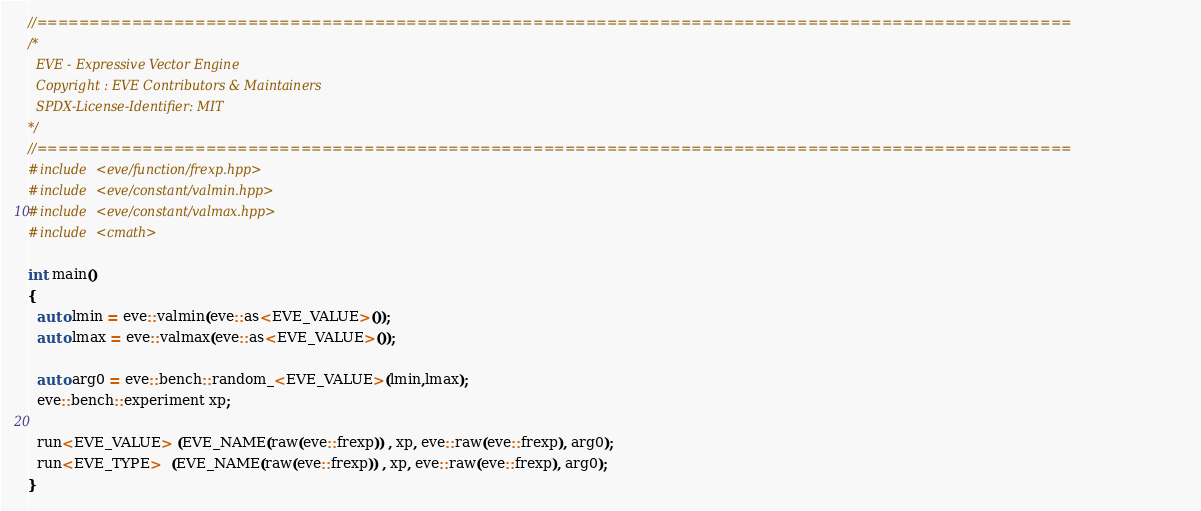Convert code to text. <code><loc_0><loc_0><loc_500><loc_500><_C++_>//==================================================================================================
/*
  EVE - Expressive Vector Engine
  Copyright : EVE Contributors & Maintainers
  SPDX-License-Identifier: MIT
*/
//==================================================================================================
#include <eve/function/frexp.hpp>
#include <eve/constant/valmin.hpp>
#include <eve/constant/valmax.hpp>
#include <cmath>

int main()
{
  auto lmin = eve::valmin(eve::as<EVE_VALUE>());
  auto lmax = eve::valmax(eve::as<EVE_VALUE>());

  auto arg0 = eve::bench::random_<EVE_VALUE>(lmin,lmax);
  eve::bench::experiment xp;

  run<EVE_VALUE> (EVE_NAME(raw(eve::frexp)) , xp, eve::raw(eve::frexp), arg0);
  run<EVE_TYPE>  (EVE_NAME(raw(eve::frexp)) , xp, eve::raw(eve::frexp), arg0);
}
</code> 